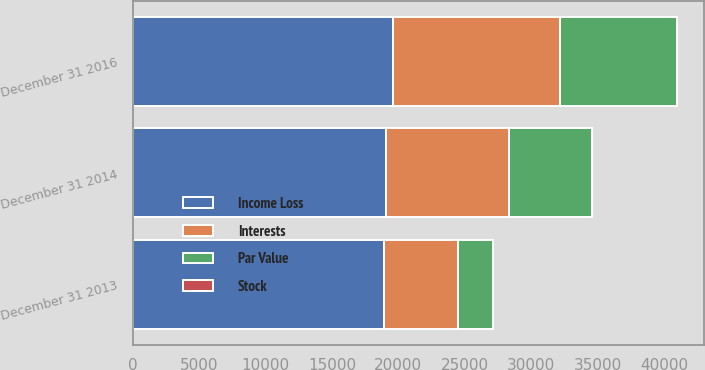<chart> <loc_0><loc_0><loc_500><loc_500><stacked_bar_chart><ecel><fcel>December 31 2013<fcel>December 31 2014<fcel>December 31 2016<nl><fcel>Stock<fcel>6<fcel>6<fcel>6<nl><fcel>Income Loss<fcel>18887<fcel>19040<fcel>19559<nl><fcel>Par Value<fcel>2602<fcel>6234<fcel>8788<nl><fcel>Interests<fcel>5622<fcel>9309<fcel>12608<nl></chart> 